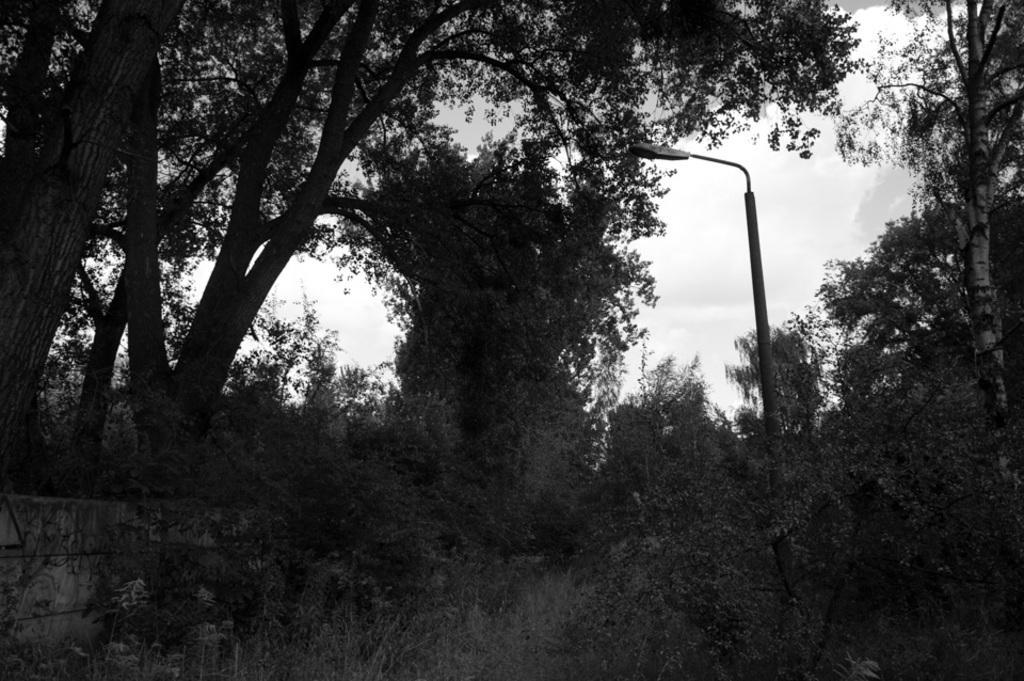Could you give a brief overview of what you see in this image? This image consists of trees and plants. This is black and white image. There is light in the middle. 